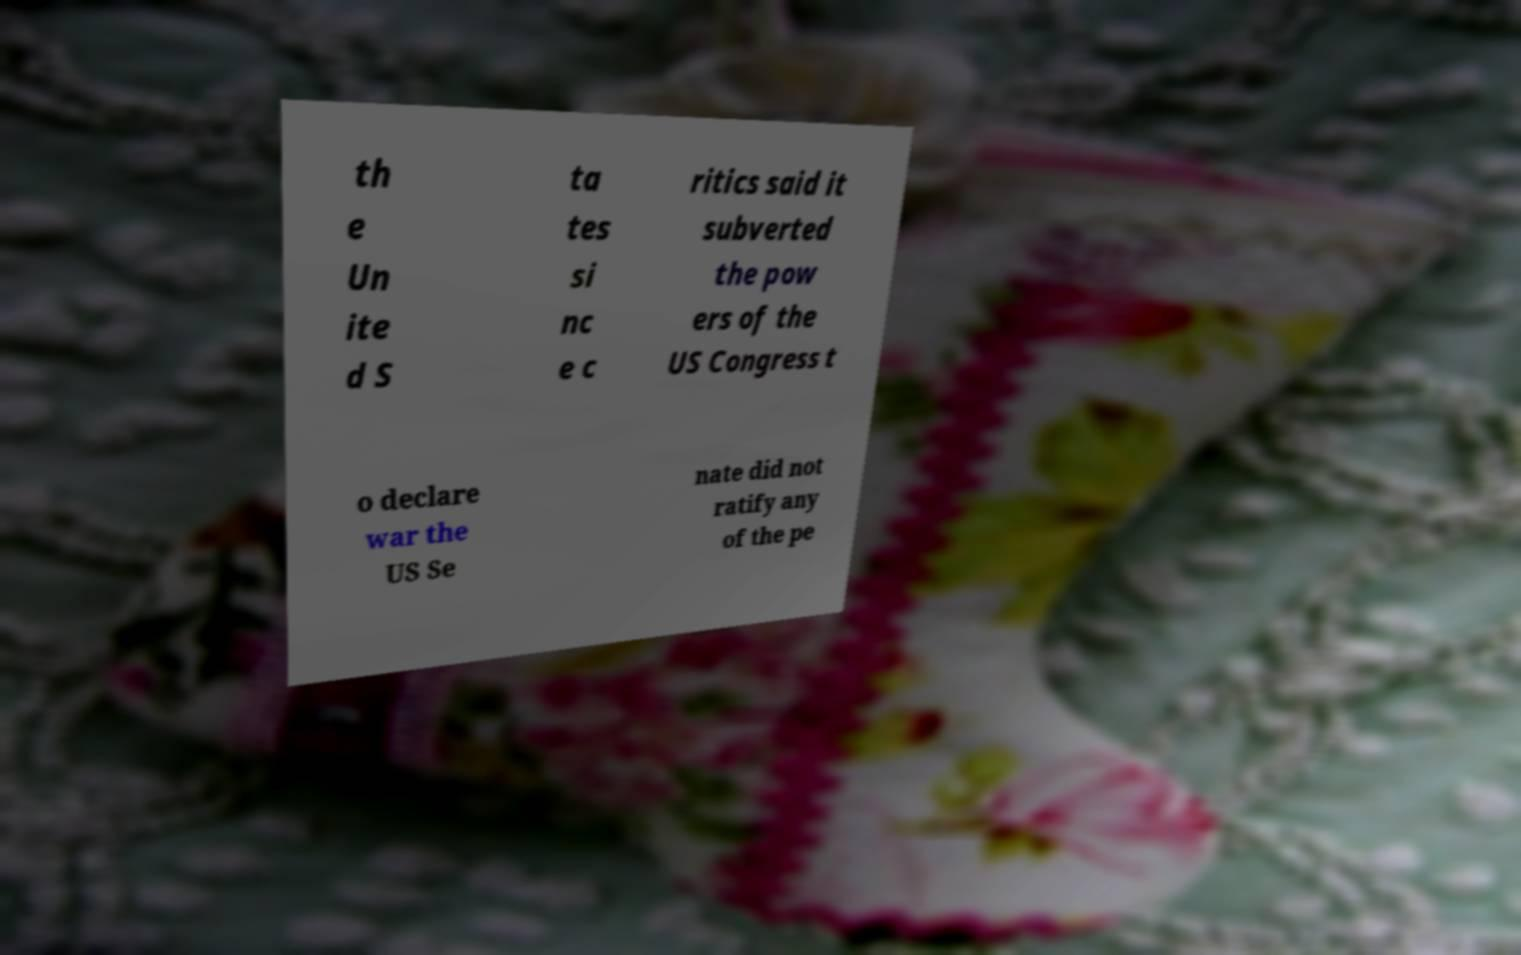Please read and relay the text visible in this image. What does it say? th e Un ite d S ta tes si nc e c ritics said it subverted the pow ers of the US Congress t o declare war the US Se nate did not ratify any of the pe 